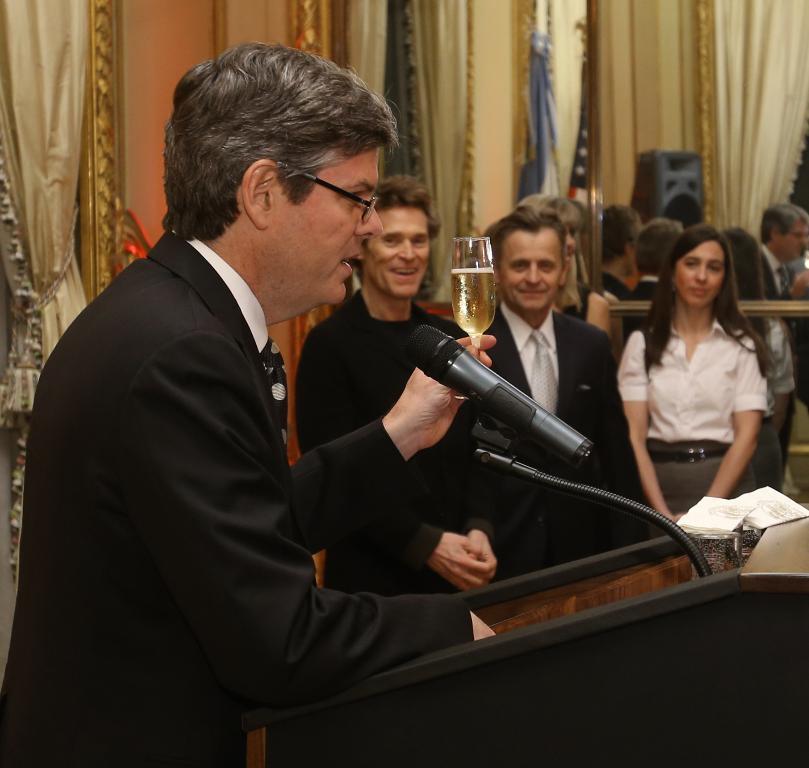Could you give a brief overview of what you see in this image? In this image I can see a person standing in front of podium , on the podium I can see a mike, person holding a glass, in the middle I can see persons , curtains and speakers visible in front of curtain. 